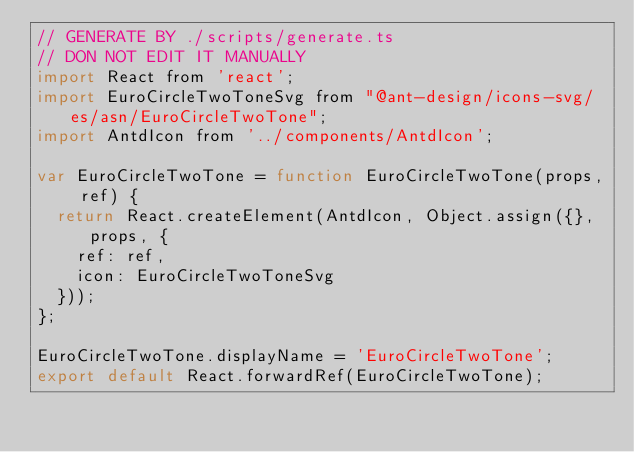<code> <loc_0><loc_0><loc_500><loc_500><_JavaScript_>// GENERATE BY ./scripts/generate.ts
// DON NOT EDIT IT MANUALLY
import React from 'react';
import EuroCircleTwoToneSvg from "@ant-design/icons-svg/es/asn/EuroCircleTwoTone";
import AntdIcon from '../components/AntdIcon';

var EuroCircleTwoTone = function EuroCircleTwoTone(props, ref) {
  return React.createElement(AntdIcon, Object.assign({}, props, {
    ref: ref,
    icon: EuroCircleTwoToneSvg
  }));
};

EuroCircleTwoTone.displayName = 'EuroCircleTwoTone';
export default React.forwardRef(EuroCircleTwoTone);</code> 